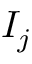Convert formula to latex. <formula><loc_0><loc_0><loc_500><loc_500>I _ { j }</formula> 